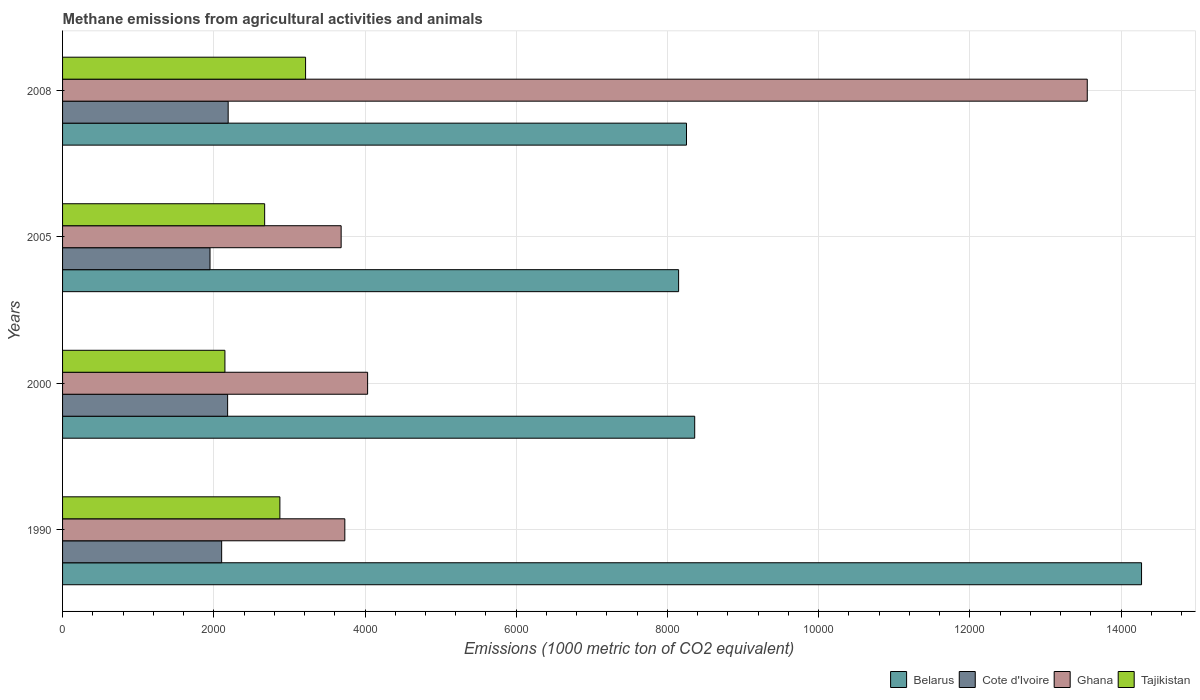How many different coloured bars are there?
Your answer should be very brief. 4. How many groups of bars are there?
Your response must be concise. 4. Are the number of bars per tick equal to the number of legend labels?
Provide a succinct answer. Yes. Are the number of bars on each tick of the Y-axis equal?
Provide a succinct answer. Yes. How many bars are there on the 4th tick from the top?
Offer a terse response. 4. How many bars are there on the 2nd tick from the bottom?
Ensure brevity in your answer.  4. What is the label of the 2nd group of bars from the top?
Your response must be concise. 2005. In how many cases, is the number of bars for a given year not equal to the number of legend labels?
Give a very brief answer. 0. What is the amount of methane emitted in Cote d'Ivoire in 2005?
Your response must be concise. 1950.1. Across all years, what is the maximum amount of methane emitted in Tajikistan?
Offer a terse response. 3214.1. Across all years, what is the minimum amount of methane emitted in Cote d'Ivoire?
Make the answer very short. 1950.1. In which year was the amount of methane emitted in Tajikistan minimum?
Offer a terse response. 2000. What is the total amount of methane emitted in Tajikistan in the graph?
Provide a short and direct response. 1.09e+04. What is the difference between the amount of methane emitted in Cote d'Ivoire in 1990 and that in 2005?
Your answer should be compact. 153.9. What is the difference between the amount of methane emitted in Tajikistan in 2005 and the amount of methane emitted in Cote d'Ivoire in 2000?
Keep it short and to the point. 489.6. What is the average amount of methane emitted in Cote d'Ivoire per year?
Your response must be concise. 2106.88. In the year 1990, what is the difference between the amount of methane emitted in Belarus and amount of methane emitted in Ghana?
Your answer should be compact. 1.05e+04. In how many years, is the amount of methane emitted in Tajikistan greater than 8000 1000 metric ton?
Ensure brevity in your answer.  0. What is the ratio of the amount of methane emitted in Cote d'Ivoire in 2005 to that in 2008?
Give a very brief answer. 0.89. Is the difference between the amount of methane emitted in Belarus in 1990 and 2000 greater than the difference between the amount of methane emitted in Ghana in 1990 and 2000?
Keep it short and to the point. Yes. What is the difference between the highest and the second highest amount of methane emitted in Ghana?
Offer a terse response. 9517.9. What is the difference between the highest and the lowest amount of methane emitted in Ghana?
Offer a terse response. 9868. Is the sum of the amount of methane emitted in Belarus in 2000 and 2005 greater than the maximum amount of methane emitted in Ghana across all years?
Provide a short and direct response. Yes. What does the 4th bar from the top in 2008 represents?
Ensure brevity in your answer.  Belarus. What does the 3rd bar from the bottom in 2005 represents?
Ensure brevity in your answer.  Ghana. How many bars are there?
Provide a short and direct response. 16. How many years are there in the graph?
Provide a succinct answer. 4. What is the difference between two consecutive major ticks on the X-axis?
Your response must be concise. 2000. Are the values on the major ticks of X-axis written in scientific E-notation?
Your answer should be very brief. No. Does the graph contain grids?
Make the answer very short. Yes. Where does the legend appear in the graph?
Offer a very short reply. Bottom right. How many legend labels are there?
Offer a terse response. 4. How are the legend labels stacked?
Offer a very short reply. Horizontal. What is the title of the graph?
Provide a succinct answer. Methane emissions from agricultural activities and animals. Does "Bulgaria" appear as one of the legend labels in the graph?
Your answer should be very brief. No. What is the label or title of the X-axis?
Offer a terse response. Emissions (1000 metric ton of CO2 equivalent). What is the Emissions (1000 metric ton of CO2 equivalent) in Belarus in 1990?
Provide a short and direct response. 1.43e+04. What is the Emissions (1000 metric ton of CO2 equivalent) in Cote d'Ivoire in 1990?
Make the answer very short. 2104. What is the Emissions (1000 metric ton of CO2 equivalent) in Ghana in 1990?
Make the answer very short. 3733.1. What is the Emissions (1000 metric ton of CO2 equivalent) in Tajikistan in 1990?
Make the answer very short. 2874.3. What is the Emissions (1000 metric ton of CO2 equivalent) of Belarus in 2000?
Keep it short and to the point. 8360.4. What is the Emissions (1000 metric ton of CO2 equivalent) in Cote d'Ivoire in 2000?
Your answer should be very brief. 2183.1. What is the Emissions (1000 metric ton of CO2 equivalent) of Ghana in 2000?
Provide a short and direct response. 4034.5. What is the Emissions (1000 metric ton of CO2 equivalent) of Tajikistan in 2000?
Your response must be concise. 2147.2. What is the Emissions (1000 metric ton of CO2 equivalent) in Belarus in 2005?
Offer a very short reply. 8147.7. What is the Emissions (1000 metric ton of CO2 equivalent) of Cote d'Ivoire in 2005?
Offer a very short reply. 1950.1. What is the Emissions (1000 metric ton of CO2 equivalent) in Ghana in 2005?
Your response must be concise. 3684.4. What is the Emissions (1000 metric ton of CO2 equivalent) of Tajikistan in 2005?
Offer a very short reply. 2672.7. What is the Emissions (1000 metric ton of CO2 equivalent) in Belarus in 2008?
Keep it short and to the point. 8252. What is the Emissions (1000 metric ton of CO2 equivalent) of Cote d'Ivoire in 2008?
Ensure brevity in your answer.  2190.3. What is the Emissions (1000 metric ton of CO2 equivalent) of Ghana in 2008?
Your response must be concise. 1.36e+04. What is the Emissions (1000 metric ton of CO2 equivalent) of Tajikistan in 2008?
Your response must be concise. 3214.1. Across all years, what is the maximum Emissions (1000 metric ton of CO2 equivalent) in Belarus?
Make the answer very short. 1.43e+04. Across all years, what is the maximum Emissions (1000 metric ton of CO2 equivalent) of Cote d'Ivoire?
Your response must be concise. 2190.3. Across all years, what is the maximum Emissions (1000 metric ton of CO2 equivalent) in Ghana?
Ensure brevity in your answer.  1.36e+04. Across all years, what is the maximum Emissions (1000 metric ton of CO2 equivalent) in Tajikistan?
Your response must be concise. 3214.1. Across all years, what is the minimum Emissions (1000 metric ton of CO2 equivalent) in Belarus?
Offer a terse response. 8147.7. Across all years, what is the minimum Emissions (1000 metric ton of CO2 equivalent) of Cote d'Ivoire?
Offer a very short reply. 1950.1. Across all years, what is the minimum Emissions (1000 metric ton of CO2 equivalent) in Ghana?
Provide a short and direct response. 3684.4. Across all years, what is the minimum Emissions (1000 metric ton of CO2 equivalent) in Tajikistan?
Offer a terse response. 2147.2. What is the total Emissions (1000 metric ton of CO2 equivalent) in Belarus in the graph?
Give a very brief answer. 3.90e+04. What is the total Emissions (1000 metric ton of CO2 equivalent) in Cote d'Ivoire in the graph?
Give a very brief answer. 8427.5. What is the total Emissions (1000 metric ton of CO2 equivalent) of Ghana in the graph?
Provide a short and direct response. 2.50e+04. What is the total Emissions (1000 metric ton of CO2 equivalent) in Tajikistan in the graph?
Your response must be concise. 1.09e+04. What is the difference between the Emissions (1000 metric ton of CO2 equivalent) in Belarus in 1990 and that in 2000?
Keep it short and to the point. 5909.9. What is the difference between the Emissions (1000 metric ton of CO2 equivalent) in Cote d'Ivoire in 1990 and that in 2000?
Your answer should be very brief. -79.1. What is the difference between the Emissions (1000 metric ton of CO2 equivalent) in Ghana in 1990 and that in 2000?
Give a very brief answer. -301.4. What is the difference between the Emissions (1000 metric ton of CO2 equivalent) in Tajikistan in 1990 and that in 2000?
Give a very brief answer. 727.1. What is the difference between the Emissions (1000 metric ton of CO2 equivalent) of Belarus in 1990 and that in 2005?
Ensure brevity in your answer.  6122.6. What is the difference between the Emissions (1000 metric ton of CO2 equivalent) in Cote d'Ivoire in 1990 and that in 2005?
Make the answer very short. 153.9. What is the difference between the Emissions (1000 metric ton of CO2 equivalent) in Ghana in 1990 and that in 2005?
Keep it short and to the point. 48.7. What is the difference between the Emissions (1000 metric ton of CO2 equivalent) in Tajikistan in 1990 and that in 2005?
Offer a very short reply. 201.6. What is the difference between the Emissions (1000 metric ton of CO2 equivalent) in Belarus in 1990 and that in 2008?
Offer a very short reply. 6018.3. What is the difference between the Emissions (1000 metric ton of CO2 equivalent) in Cote d'Ivoire in 1990 and that in 2008?
Give a very brief answer. -86.3. What is the difference between the Emissions (1000 metric ton of CO2 equivalent) in Ghana in 1990 and that in 2008?
Your response must be concise. -9819.3. What is the difference between the Emissions (1000 metric ton of CO2 equivalent) of Tajikistan in 1990 and that in 2008?
Offer a very short reply. -339.8. What is the difference between the Emissions (1000 metric ton of CO2 equivalent) of Belarus in 2000 and that in 2005?
Keep it short and to the point. 212.7. What is the difference between the Emissions (1000 metric ton of CO2 equivalent) of Cote d'Ivoire in 2000 and that in 2005?
Offer a very short reply. 233. What is the difference between the Emissions (1000 metric ton of CO2 equivalent) in Ghana in 2000 and that in 2005?
Provide a short and direct response. 350.1. What is the difference between the Emissions (1000 metric ton of CO2 equivalent) of Tajikistan in 2000 and that in 2005?
Your answer should be very brief. -525.5. What is the difference between the Emissions (1000 metric ton of CO2 equivalent) of Belarus in 2000 and that in 2008?
Offer a terse response. 108.4. What is the difference between the Emissions (1000 metric ton of CO2 equivalent) in Ghana in 2000 and that in 2008?
Your answer should be very brief. -9517.9. What is the difference between the Emissions (1000 metric ton of CO2 equivalent) of Tajikistan in 2000 and that in 2008?
Your answer should be compact. -1066.9. What is the difference between the Emissions (1000 metric ton of CO2 equivalent) of Belarus in 2005 and that in 2008?
Provide a short and direct response. -104.3. What is the difference between the Emissions (1000 metric ton of CO2 equivalent) in Cote d'Ivoire in 2005 and that in 2008?
Provide a succinct answer. -240.2. What is the difference between the Emissions (1000 metric ton of CO2 equivalent) of Ghana in 2005 and that in 2008?
Offer a terse response. -9868. What is the difference between the Emissions (1000 metric ton of CO2 equivalent) of Tajikistan in 2005 and that in 2008?
Ensure brevity in your answer.  -541.4. What is the difference between the Emissions (1000 metric ton of CO2 equivalent) in Belarus in 1990 and the Emissions (1000 metric ton of CO2 equivalent) in Cote d'Ivoire in 2000?
Keep it short and to the point. 1.21e+04. What is the difference between the Emissions (1000 metric ton of CO2 equivalent) in Belarus in 1990 and the Emissions (1000 metric ton of CO2 equivalent) in Ghana in 2000?
Provide a short and direct response. 1.02e+04. What is the difference between the Emissions (1000 metric ton of CO2 equivalent) of Belarus in 1990 and the Emissions (1000 metric ton of CO2 equivalent) of Tajikistan in 2000?
Make the answer very short. 1.21e+04. What is the difference between the Emissions (1000 metric ton of CO2 equivalent) of Cote d'Ivoire in 1990 and the Emissions (1000 metric ton of CO2 equivalent) of Ghana in 2000?
Offer a terse response. -1930.5. What is the difference between the Emissions (1000 metric ton of CO2 equivalent) in Cote d'Ivoire in 1990 and the Emissions (1000 metric ton of CO2 equivalent) in Tajikistan in 2000?
Your answer should be compact. -43.2. What is the difference between the Emissions (1000 metric ton of CO2 equivalent) in Ghana in 1990 and the Emissions (1000 metric ton of CO2 equivalent) in Tajikistan in 2000?
Offer a very short reply. 1585.9. What is the difference between the Emissions (1000 metric ton of CO2 equivalent) of Belarus in 1990 and the Emissions (1000 metric ton of CO2 equivalent) of Cote d'Ivoire in 2005?
Give a very brief answer. 1.23e+04. What is the difference between the Emissions (1000 metric ton of CO2 equivalent) in Belarus in 1990 and the Emissions (1000 metric ton of CO2 equivalent) in Ghana in 2005?
Your response must be concise. 1.06e+04. What is the difference between the Emissions (1000 metric ton of CO2 equivalent) in Belarus in 1990 and the Emissions (1000 metric ton of CO2 equivalent) in Tajikistan in 2005?
Your answer should be compact. 1.16e+04. What is the difference between the Emissions (1000 metric ton of CO2 equivalent) in Cote d'Ivoire in 1990 and the Emissions (1000 metric ton of CO2 equivalent) in Ghana in 2005?
Keep it short and to the point. -1580.4. What is the difference between the Emissions (1000 metric ton of CO2 equivalent) in Cote d'Ivoire in 1990 and the Emissions (1000 metric ton of CO2 equivalent) in Tajikistan in 2005?
Provide a short and direct response. -568.7. What is the difference between the Emissions (1000 metric ton of CO2 equivalent) of Ghana in 1990 and the Emissions (1000 metric ton of CO2 equivalent) of Tajikistan in 2005?
Offer a terse response. 1060.4. What is the difference between the Emissions (1000 metric ton of CO2 equivalent) of Belarus in 1990 and the Emissions (1000 metric ton of CO2 equivalent) of Cote d'Ivoire in 2008?
Your answer should be very brief. 1.21e+04. What is the difference between the Emissions (1000 metric ton of CO2 equivalent) in Belarus in 1990 and the Emissions (1000 metric ton of CO2 equivalent) in Ghana in 2008?
Offer a very short reply. 717.9. What is the difference between the Emissions (1000 metric ton of CO2 equivalent) in Belarus in 1990 and the Emissions (1000 metric ton of CO2 equivalent) in Tajikistan in 2008?
Ensure brevity in your answer.  1.11e+04. What is the difference between the Emissions (1000 metric ton of CO2 equivalent) in Cote d'Ivoire in 1990 and the Emissions (1000 metric ton of CO2 equivalent) in Ghana in 2008?
Your answer should be compact. -1.14e+04. What is the difference between the Emissions (1000 metric ton of CO2 equivalent) in Cote d'Ivoire in 1990 and the Emissions (1000 metric ton of CO2 equivalent) in Tajikistan in 2008?
Ensure brevity in your answer.  -1110.1. What is the difference between the Emissions (1000 metric ton of CO2 equivalent) in Ghana in 1990 and the Emissions (1000 metric ton of CO2 equivalent) in Tajikistan in 2008?
Offer a terse response. 519. What is the difference between the Emissions (1000 metric ton of CO2 equivalent) in Belarus in 2000 and the Emissions (1000 metric ton of CO2 equivalent) in Cote d'Ivoire in 2005?
Keep it short and to the point. 6410.3. What is the difference between the Emissions (1000 metric ton of CO2 equivalent) in Belarus in 2000 and the Emissions (1000 metric ton of CO2 equivalent) in Ghana in 2005?
Your response must be concise. 4676. What is the difference between the Emissions (1000 metric ton of CO2 equivalent) in Belarus in 2000 and the Emissions (1000 metric ton of CO2 equivalent) in Tajikistan in 2005?
Provide a succinct answer. 5687.7. What is the difference between the Emissions (1000 metric ton of CO2 equivalent) of Cote d'Ivoire in 2000 and the Emissions (1000 metric ton of CO2 equivalent) of Ghana in 2005?
Keep it short and to the point. -1501.3. What is the difference between the Emissions (1000 metric ton of CO2 equivalent) of Cote d'Ivoire in 2000 and the Emissions (1000 metric ton of CO2 equivalent) of Tajikistan in 2005?
Provide a succinct answer. -489.6. What is the difference between the Emissions (1000 metric ton of CO2 equivalent) in Ghana in 2000 and the Emissions (1000 metric ton of CO2 equivalent) in Tajikistan in 2005?
Offer a terse response. 1361.8. What is the difference between the Emissions (1000 metric ton of CO2 equivalent) in Belarus in 2000 and the Emissions (1000 metric ton of CO2 equivalent) in Cote d'Ivoire in 2008?
Offer a very short reply. 6170.1. What is the difference between the Emissions (1000 metric ton of CO2 equivalent) in Belarus in 2000 and the Emissions (1000 metric ton of CO2 equivalent) in Ghana in 2008?
Provide a short and direct response. -5192. What is the difference between the Emissions (1000 metric ton of CO2 equivalent) in Belarus in 2000 and the Emissions (1000 metric ton of CO2 equivalent) in Tajikistan in 2008?
Your response must be concise. 5146.3. What is the difference between the Emissions (1000 metric ton of CO2 equivalent) in Cote d'Ivoire in 2000 and the Emissions (1000 metric ton of CO2 equivalent) in Ghana in 2008?
Provide a short and direct response. -1.14e+04. What is the difference between the Emissions (1000 metric ton of CO2 equivalent) in Cote d'Ivoire in 2000 and the Emissions (1000 metric ton of CO2 equivalent) in Tajikistan in 2008?
Keep it short and to the point. -1031. What is the difference between the Emissions (1000 metric ton of CO2 equivalent) in Ghana in 2000 and the Emissions (1000 metric ton of CO2 equivalent) in Tajikistan in 2008?
Provide a short and direct response. 820.4. What is the difference between the Emissions (1000 metric ton of CO2 equivalent) in Belarus in 2005 and the Emissions (1000 metric ton of CO2 equivalent) in Cote d'Ivoire in 2008?
Offer a very short reply. 5957.4. What is the difference between the Emissions (1000 metric ton of CO2 equivalent) in Belarus in 2005 and the Emissions (1000 metric ton of CO2 equivalent) in Ghana in 2008?
Provide a short and direct response. -5404.7. What is the difference between the Emissions (1000 metric ton of CO2 equivalent) of Belarus in 2005 and the Emissions (1000 metric ton of CO2 equivalent) of Tajikistan in 2008?
Your answer should be compact. 4933.6. What is the difference between the Emissions (1000 metric ton of CO2 equivalent) of Cote d'Ivoire in 2005 and the Emissions (1000 metric ton of CO2 equivalent) of Ghana in 2008?
Provide a short and direct response. -1.16e+04. What is the difference between the Emissions (1000 metric ton of CO2 equivalent) of Cote d'Ivoire in 2005 and the Emissions (1000 metric ton of CO2 equivalent) of Tajikistan in 2008?
Your answer should be compact. -1264. What is the difference between the Emissions (1000 metric ton of CO2 equivalent) of Ghana in 2005 and the Emissions (1000 metric ton of CO2 equivalent) of Tajikistan in 2008?
Make the answer very short. 470.3. What is the average Emissions (1000 metric ton of CO2 equivalent) in Belarus per year?
Offer a terse response. 9757.6. What is the average Emissions (1000 metric ton of CO2 equivalent) of Cote d'Ivoire per year?
Offer a very short reply. 2106.88. What is the average Emissions (1000 metric ton of CO2 equivalent) in Ghana per year?
Offer a terse response. 6251.1. What is the average Emissions (1000 metric ton of CO2 equivalent) in Tajikistan per year?
Keep it short and to the point. 2727.07. In the year 1990, what is the difference between the Emissions (1000 metric ton of CO2 equivalent) in Belarus and Emissions (1000 metric ton of CO2 equivalent) in Cote d'Ivoire?
Provide a succinct answer. 1.22e+04. In the year 1990, what is the difference between the Emissions (1000 metric ton of CO2 equivalent) in Belarus and Emissions (1000 metric ton of CO2 equivalent) in Ghana?
Your answer should be very brief. 1.05e+04. In the year 1990, what is the difference between the Emissions (1000 metric ton of CO2 equivalent) of Belarus and Emissions (1000 metric ton of CO2 equivalent) of Tajikistan?
Provide a succinct answer. 1.14e+04. In the year 1990, what is the difference between the Emissions (1000 metric ton of CO2 equivalent) of Cote d'Ivoire and Emissions (1000 metric ton of CO2 equivalent) of Ghana?
Make the answer very short. -1629.1. In the year 1990, what is the difference between the Emissions (1000 metric ton of CO2 equivalent) in Cote d'Ivoire and Emissions (1000 metric ton of CO2 equivalent) in Tajikistan?
Offer a very short reply. -770.3. In the year 1990, what is the difference between the Emissions (1000 metric ton of CO2 equivalent) in Ghana and Emissions (1000 metric ton of CO2 equivalent) in Tajikistan?
Your answer should be compact. 858.8. In the year 2000, what is the difference between the Emissions (1000 metric ton of CO2 equivalent) in Belarus and Emissions (1000 metric ton of CO2 equivalent) in Cote d'Ivoire?
Provide a succinct answer. 6177.3. In the year 2000, what is the difference between the Emissions (1000 metric ton of CO2 equivalent) in Belarus and Emissions (1000 metric ton of CO2 equivalent) in Ghana?
Provide a succinct answer. 4325.9. In the year 2000, what is the difference between the Emissions (1000 metric ton of CO2 equivalent) in Belarus and Emissions (1000 metric ton of CO2 equivalent) in Tajikistan?
Your response must be concise. 6213.2. In the year 2000, what is the difference between the Emissions (1000 metric ton of CO2 equivalent) in Cote d'Ivoire and Emissions (1000 metric ton of CO2 equivalent) in Ghana?
Ensure brevity in your answer.  -1851.4. In the year 2000, what is the difference between the Emissions (1000 metric ton of CO2 equivalent) in Cote d'Ivoire and Emissions (1000 metric ton of CO2 equivalent) in Tajikistan?
Keep it short and to the point. 35.9. In the year 2000, what is the difference between the Emissions (1000 metric ton of CO2 equivalent) in Ghana and Emissions (1000 metric ton of CO2 equivalent) in Tajikistan?
Ensure brevity in your answer.  1887.3. In the year 2005, what is the difference between the Emissions (1000 metric ton of CO2 equivalent) of Belarus and Emissions (1000 metric ton of CO2 equivalent) of Cote d'Ivoire?
Your response must be concise. 6197.6. In the year 2005, what is the difference between the Emissions (1000 metric ton of CO2 equivalent) in Belarus and Emissions (1000 metric ton of CO2 equivalent) in Ghana?
Your answer should be very brief. 4463.3. In the year 2005, what is the difference between the Emissions (1000 metric ton of CO2 equivalent) of Belarus and Emissions (1000 metric ton of CO2 equivalent) of Tajikistan?
Your answer should be very brief. 5475. In the year 2005, what is the difference between the Emissions (1000 metric ton of CO2 equivalent) of Cote d'Ivoire and Emissions (1000 metric ton of CO2 equivalent) of Ghana?
Give a very brief answer. -1734.3. In the year 2005, what is the difference between the Emissions (1000 metric ton of CO2 equivalent) of Cote d'Ivoire and Emissions (1000 metric ton of CO2 equivalent) of Tajikistan?
Your answer should be very brief. -722.6. In the year 2005, what is the difference between the Emissions (1000 metric ton of CO2 equivalent) of Ghana and Emissions (1000 metric ton of CO2 equivalent) of Tajikistan?
Provide a short and direct response. 1011.7. In the year 2008, what is the difference between the Emissions (1000 metric ton of CO2 equivalent) in Belarus and Emissions (1000 metric ton of CO2 equivalent) in Cote d'Ivoire?
Keep it short and to the point. 6061.7. In the year 2008, what is the difference between the Emissions (1000 metric ton of CO2 equivalent) in Belarus and Emissions (1000 metric ton of CO2 equivalent) in Ghana?
Provide a short and direct response. -5300.4. In the year 2008, what is the difference between the Emissions (1000 metric ton of CO2 equivalent) of Belarus and Emissions (1000 metric ton of CO2 equivalent) of Tajikistan?
Offer a terse response. 5037.9. In the year 2008, what is the difference between the Emissions (1000 metric ton of CO2 equivalent) of Cote d'Ivoire and Emissions (1000 metric ton of CO2 equivalent) of Ghana?
Give a very brief answer. -1.14e+04. In the year 2008, what is the difference between the Emissions (1000 metric ton of CO2 equivalent) of Cote d'Ivoire and Emissions (1000 metric ton of CO2 equivalent) of Tajikistan?
Provide a short and direct response. -1023.8. In the year 2008, what is the difference between the Emissions (1000 metric ton of CO2 equivalent) in Ghana and Emissions (1000 metric ton of CO2 equivalent) in Tajikistan?
Offer a terse response. 1.03e+04. What is the ratio of the Emissions (1000 metric ton of CO2 equivalent) in Belarus in 1990 to that in 2000?
Provide a short and direct response. 1.71. What is the ratio of the Emissions (1000 metric ton of CO2 equivalent) of Cote d'Ivoire in 1990 to that in 2000?
Keep it short and to the point. 0.96. What is the ratio of the Emissions (1000 metric ton of CO2 equivalent) in Ghana in 1990 to that in 2000?
Provide a succinct answer. 0.93. What is the ratio of the Emissions (1000 metric ton of CO2 equivalent) of Tajikistan in 1990 to that in 2000?
Offer a very short reply. 1.34. What is the ratio of the Emissions (1000 metric ton of CO2 equivalent) in Belarus in 1990 to that in 2005?
Your response must be concise. 1.75. What is the ratio of the Emissions (1000 metric ton of CO2 equivalent) in Cote d'Ivoire in 1990 to that in 2005?
Offer a terse response. 1.08. What is the ratio of the Emissions (1000 metric ton of CO2 equivalent) of Ghana in 1990 to that in 2005?
Provide a short and direct response. 1.01. What is the ratio of the Emissions (1000 metric ton of CO2 equivalent) in Tajikistan in 1990 to that in 2005?
Your answer should be very brief. 1.08. What is the ratio of the Emissions (1000 metric ton of CO2 equivalent) in Belarus in 1990 to that in 2008?
Your answer should be very brief. 1.73. What is the ratio of the Emissions (1000 metric ton of CO2 equivalent) of Cote d'Ivoire in 1990 to that in 2008?
Offer a terse response. 0.96. What is the ratio of the Emissions (1000 metric ton of CO2 equivalent) of Ghana in 1990 to that in 2008?
Give a very brief answer. 0.28. What is the ratio of the Emissions (1000 metric ton of CO2 equivalent) in Tajikistan in 1990 to that in 2008?
Offer a very short reply. 0.89. What is the ratio of the Emissions (1000 metric ton of CO2 equivalent) of Belarus in 2000 to that in 2005?
Your answer should be very brief. 1.03. What is the ratio of the Emissions (1000 metric ton of CO2 equivalent) in Cote d'Ivoire in 2000 to that in 2005?
Your response must be concise. 1.12. What is the ratio of the Emissions (1000 metric ton of CO2 equivalent) of Ghana in 2000 to that in 2005?
Offer a very short reply. 1.09. What is the ratio of the Emissions (1000 metric ton of CO2 equivalent) in Tajikistan in 2000 to that in 2005?
Provide a short and direct response. 0.8. What is the ratio of the Emissions (1000 metric ton of CO2 equivalent) of Belarus in 2000 to that in 2008?
Provide a short and direct response. 1.01. What is the ratio of the Emissions (1000 metric ton of CO2 equivalent) in Cote d'Ivoire in 2000 to that in 2008?
Give a very brief answer. 1. What is the ratio of the Emissions (1000 metric ton of CO2 equivalent) in Ghana in 2000 to that in 2008?
Offer a terse response. 0.3. What is the ratio of the Emissions (1000 metric ton of CO2 equivalent) of Tajikistan in 2000 to that in 2008?
Make the answer very short. 0.67. What is the ratio of the Emissions (1000 metric ton of CO2 equivalent) of Belarus in 2005 to that in 2008?
Make the answer very short. 0.99. What is the ratio of the Emissions (1000 metric ton of CO2 equivalent) of Cote d'Ivoire in 2005 to that in 2008?
Your response must be concise. 0.89. What is the ratio of the Emissions (1000 metric ton of CO2 equivalent) in Ghana in 2005 to that in 2008?
Offer a very short reply. 0.27. What is the ratio of the Emissions (1000 metric ton of CO2 equivalent) in Tajikistan in 2005 to that in 2008?
Give a very brief answer. 0.83. What is the difference between the highest and the second highest Emissions (1000 metric ton of CO2 equivalent) in Belarus?
Ensure brevity in your answer.  5909.9. What is the difference between the highest and the second highest Emissions (1000 metric ton of CO2 equivalent) of Cote d'Ivoire?
Your answer should be very brief. 7.2. What is the difference between the highest and the second highest Emissions (1000 metric ton of CO2 equivalent) in Ghana?
Offer a very short reply. 9517.9. What is the difference between the highest and the second highest Emissions (1000 metric ton of CO2 equivalent) of Tajikistan?
Ensure brevity in your answer.  339.8. What is the difference between the highest and the lowest Emissions (1000 metric ton of CO2 equivalent) in Belarus?
Provide a succinct answer. 6122.6. What is the difference between the highest and the lowest Emissions (1000 metric ton of CO2 equivalent) of Cote d'Ivoire?
Provide a succinct answer. 240.2. What is the difference between the highest and the lowest Emissions (1000 metric ton of CO2 equivalent) in Ghana?
Give a very brief answer. 9868. What is the difference between the highest and the lowest Emissions (1000 metric ton of CO2 equivalent) in Tajikistan?
Your answer should be compact. 1066.9. 